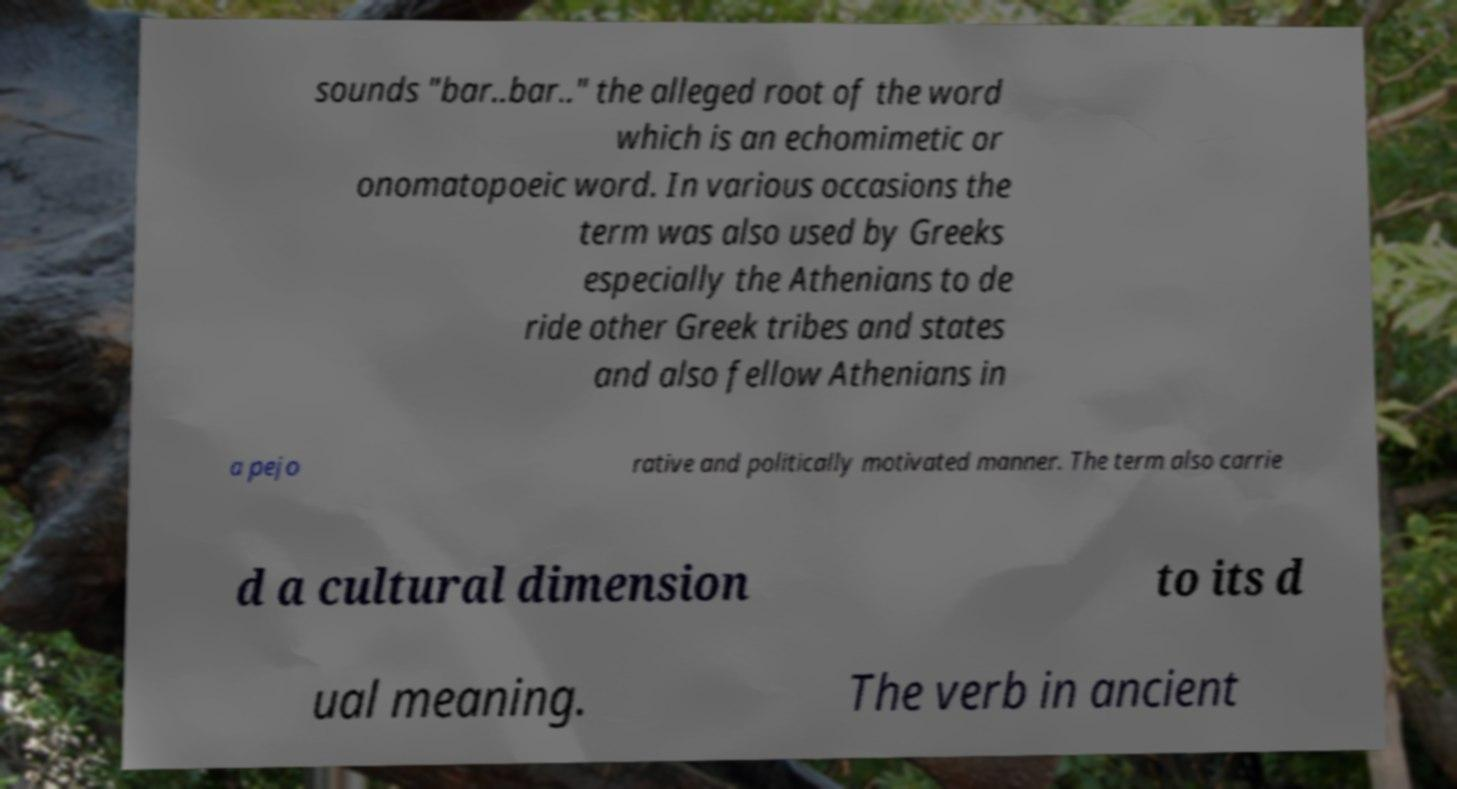What messages or text are displayed in this image? I need them in a readable, typed format. sounds "bar..bar.." the alleged root of the word which is an echomimetic or onomatopoeic word. In various occasions the term was also used by Greeks especially the Athenians to de ride other Greek tribes and states and also fellow Athenians in a pejo rative and politically motivated manner. The term also carrie d a cultural dimension to its d ual meaning. The verb in ancient 